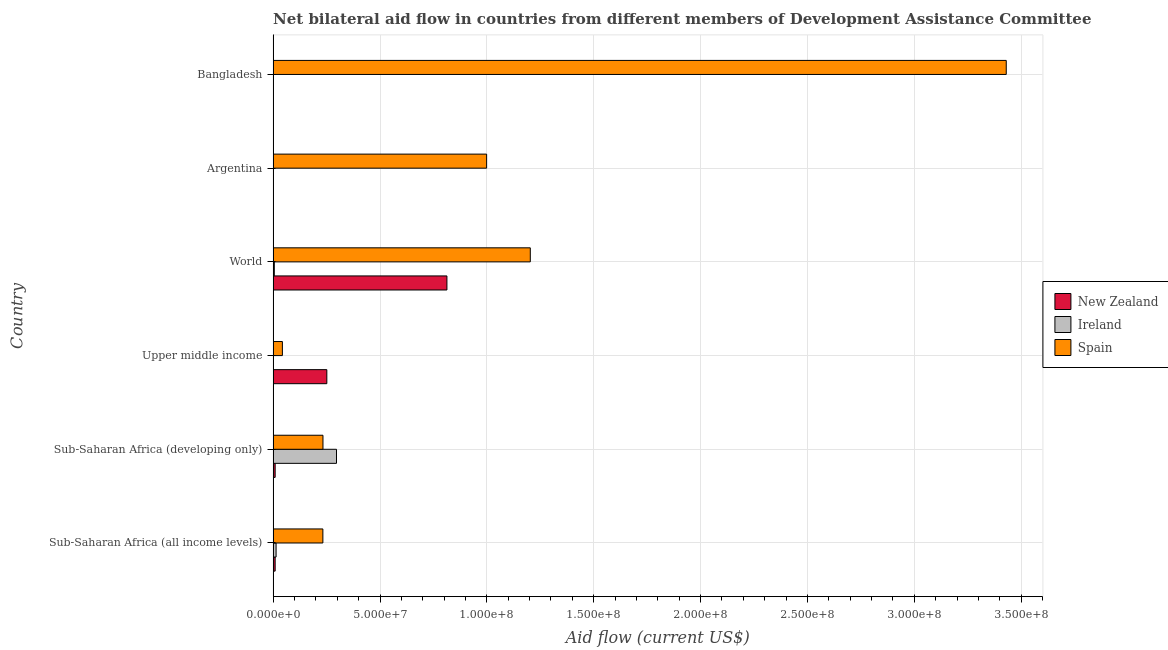How many different coloured bars are there?
Provide a succinct answer. 3. How many bars are there on the 3rd tick from the top?
Your answer should be compact. 3. How many bars are there on the 6th tick from the bottom?
Your answer should be very brief. 3. What is the label of the 1st group of bars from the top?
Ensure brevity in your answer.  Bangladesh. In how many cases, is the number of bars for a given country not equal to the number of legend labels?
Give a very brief answer. 0. What is the amount of aid provided by spain in Upper middle income?
Offer a terse response. 4.34e+06. Across all countries, what is the maximum amount of aid provided by new zealand?
Ensure brevity in your answer.  8.13e+07. Across all countries, what is the minimum amount of aid provided by ireland?
Keep it short and to the point. 2.00e+04. In which country was the amount of aid provided by spain maximum?
Your response must be concise. Bangladesh. In which country was the amount of aid provided by spain minimum?
Your answer should be very brief. Upper middle income. What is the total amount of aid provided by ireland in the graph?
Keep it short and to the point. 3.17e+07. What is the difference between the amount of aid provided by ireland in Sub-Saharan Africa (all income levels) and that in Upper middle income?
Provide a succinct answer. 1.30e+06. What is the difference between the amount of aid provided by ireland in World and the amount of aid provided by new zealand in Upper middle income?
Your answer should be compact. -2.46e+07. What is the average amount of aid provided by new zealand per country?
Your answer should be compact. 1.81e+07. What is the difference between the amount of aid provided by spain and amount of aid provided by ireland in Bangladesh?
Ensure brevity in your answer.  3.43e+08. In how many countries, is the amount of aid provided by spain greater than 50000000 US$?
Ensure brevity in your answer.  3. What is the ratio of the amount of aid provided by new zealand in Bangladesh to that in Sub-Saharan Africa (all income levels)?
Offer a very short reply. 0.05. What is the difference between the highest and the second highest amount of aid provided by ireland?
Ensure brevity in your answer.  2.83e+07. What is the difference between the highest and the lowest amount of aid provided by new zealand?
Offer a terse response. 8.13e+07. In how many countries, is the amount of aid provided by ireland greater than the average amount of aid provided by ireland taken over all countries?
Provide a succinct answer. 1. What does the 3rd bar from the top in Sub-Saharan Africa (developing only) represents?
Your response must be concise. New Zealand. How many bars are there?
Your response must be concise. 18. Are all the bars in the graph horizontal?
Offer a terse response. Yes. How many countries are there in the graph?
Make the answer very short. 6. Are the values on the major ticks of X-axis written in scientific E-notation?
Make the answer very short. Yes. Does the graph contain any zero values?
Make the answer very short. No. Does the graph contain grids?
Your answer should be very brief. Yes. Where does the legend appear in the graph?
Your answer should be very brief. Center right. How are the legend labels stacked?
Your answer should be compact. Vertical. What is the title of the graph?
Ensure brevity in your answer.  Net bilateral aid flow in countries from different members of Development Assistance Committee. What is the label or title of the Y-axis?
Offer a very short reply. Country. What is the Aid flow (current US$) in New Zealand in Sub-Saharan Africa (all income levels)?
Ensure brevity in your answer.  9.50e+05. What is the Aid flow (current US$) of Ireland in Sub-Saharan Africa (all income levels)?
Your response must be concise. 1.39e+06. What is the Aid flow (current US$) of Spain in Sub-Saharan Africa (all income levels)?
Give a very brief answer. 2.33e+07. What is the Aid flow (current US$) in New Zealand in Sub-Saharan Africa (developing only)?
Your response must be concise. 9.50e+05. What is the Aid flow (current US$) in Ireland in Sub-Saharan Africa (developing only)?
Give a very brief answer. 2.96e+07. What is the Aid flow (current US$) in Spain in Sub-Saharan Africa (developing only)?
Ensure brevity in your answer.  2.33e+07. What is the Aid flow (current US$) of New Zealand in Upper middle income?
Provide a succinct answer. 2.51e+07. What is the Aid flow (current US$) of Ireland in Upper middle income?
Make the answer very short. 9.00e+04. What is the Aid flow (current US$) in Spain in Upper middle income?
Provide a short and direct response. 4.34e+06. What is the Aid flow (current US$) of New Zealand in World?
Ensure brevity in your answer.  8.13e+07. What is the Aid flow (current US$) of Ireland in World?
Your response must be concise. 5.60e+05. What is the Aid flow (current US$) in Spain in World?
Offer a very short reply. 1.20e+08. What is the Aid flow (current US$) of New Zealand in Argentina?
Your answer should be compact. 3.00e+04. What is the Aid flow (current US$) in Ireland in Argentina?
Ensure brevity in your answer.  2.00e+04. What is the Aid flow (current US$) of Spain in Argentina?
Provide a short and direct response. 9.99e+07. What is the Aid flow (current US$) of Spain in Bangladesh?
Make the answer very short. 3.43e+08. Across all countries, what is the maximum Aid flow (current US$) in New Zealand?
Provide a succinct answer. 8.13e+07. Across all countries, what is the maximum Aid flow (current US$) in Ireland?
Your answer should be very brief. 2.96e+07. Across all countries, what is the maximum Aid flow (current US$) of Spain?
Your answer should be compact. 3.43e+08. Across all countries, what is the minimum Aid flow (current US$) in New Zealand?
Offer a terse response. 3.00e+04. Across all countries, what is the minimum Aid flow (current US$) in Spain?
Provide a short and direct response. 4.34e+06. What is the total Aid flow (current US$) of New Zealand in the graph?
Offer a very short reply. 1.08e+08. What is the total Aid flow (current US$) of Ireland in the graph?
Keep it short and to the point. 3.17e+07. What is the total Aid flow (current US$) of Spain in the graph?
Your answer should be very brief. 6.14e+08. What is the difference between the Aid flow (current US$) in Ireland in Sub-Saharan Africa (all income levels) and that in Sub-Saharan Africa (developing only)?
Ensure brevity in your answer.  -2.83e+07. What is the difference between the Aid flow (current US$) of New Zealand in Sub-Saharan Africa (all income levels) and that in Upper middle income?
Offer a very short reply. -2.42e+07. What is the difference between the Aid flow (current US$) in Ireland in Sub-Saharan Africa (all income levels) and that in Upper middle income?
Offer a very short reply. 1.30e+06. What is the difference between the Aid flow (current US$) in Spain in Sub-Saharan Africa (all income levels) and that in Upper middle income?
Provide a short and direct response. 1.89e+07. What is the difference between the Aid flow (current US$) of New Zealand in Sub-Saharan Africa (all income levels) and that in World?
Provide a succinct answer. -8.04e+07. What is the difference between the Aid flow (current US$) of Ireland in Sub-Saharan Africa (all income levels) and that in World?
Ensure brevity in your answer.  8.30e+05. What is the difference between the Aid flow (current US$) of Spain in Sub-Saharan Africa (all income levels) and that in World?
Your response must be concise. -9.70e+07. What is the difference between the Aid flow (current US$) in New Zealand in Sub-Saharan Africa (all income levels) and that in Argentina?
Your answer should be compact. 9.20e+05. What is the difference between the Aid flow (current US$) of Ireland in Sub-Saharan Africa (all income levels) and that in Argentina?
Keep it short and to the point. 1.37e+06. What is the difference between the Aid flow (current US$) in Spain in Sub-Saharan Africa (all income levels) and that in Argentina?
Ensure brevity in your answer.  -7.66e+07. What is the difference between the Aid flow (current US$) in Ireland in Sub-Saharan Africa (all income levels) and that in Bangladesh?
Your response must be concise. 1.37e+06. What is the difference between the Aid flow (current US$) in Spain in Sub-Saharan Africa (all income levels) and that in Bangladesh?
Make the answer very short. -3.20e+08. What is the difference between the Aid flow (current US$) of New Zealand in Sub-Saharan Africa (developing only) and that in Upper middle income?
Ensure brevity in your answer.  -2.42e+07. What is the difference between the Aid flow (current US$) of Ireland in Sub-Saharan Africa (developing only) and that in Upper middle income?
Your answer should be compact. 2.96e+07. What is the difference between the Aid flow (current US$) in Spain in Sub-Saharan Africa (developing only) and that in Upper middle income?
Give a very brief answer. 1.90e+07. What is the difference between the Aid flow (current US$) in New Zealand in Sub-Saharan Africa (developing only) and that in World?
Ensure brevity in your answer.  -8.04e+07. What is the difference between the Aid flow (current US$) of Ireland in Sub-Saharan Africa (developing only) and that in World?
Offer a very short reply. 2.91e+07. What is the difference between the Aid flow (current US$) of Spain in Sub-Saharan Africa (developing only) and that in World?
Offer a terse response. -9.70e+07. What is the difference between the Aid flow (current US$) in New Zealand in Sub-Saharan Africa (developing only) and that in Argentina?
Keep it short and to the point. 9.20e+05. What is the difference between the Aid flow (current US$) in Ireland in Sub-Saharan Africa (developing only) and that in Argentina?
Offer a terse response. 2.96e+07. What is the difference between the Aid flow (current US$) of Spain in Sub-Saharan Africa (developing only) and that in Argentina?
Make the answer very short. -7.66e+07. What is the difference between the Aid flow (current US$) in New Zealand in Sub-Saharan Africa (developing only) and that in Bangladesh?
Provide a short and direct response. 9.00e+05. What is the difference between the Aid flow (current US$) in Ireland in Sub-Saharan Africa (developing only) and that in Bangladesh?
Your answer should be very brief. 2.96e+07. What is the difference between the Aid flow (current US$) of Spain in Sub-Saharan Africa (developing only) and that in Bangladesh?
Your response must be concise. -3.20e+08. What is the difference between the Aid flow (current US$) of New Zealand in Upper middle income and that in World?
Give a very brief answer. -5.62e+07. What is the difference between the Aid flow (current US$) in Ireland in Upper middle income and that in World?
Your answer should be compact. -4.70e+05. What is the difference between the Aid flow (current US$) in Spain in Upper middle income and that in World?
Your answer should be compact. -1.16e+08. What is the difference between the Aid flow (current US$) of New Zealand in Upper middle income and that in Argentina?
Ensure brevity in your answer.  2.51e+07. What is the difference between the Aid flow (current US$) in Ireland in Upper middle income and that in Argentina?
Provide a short and direct response. 7.00e+04. What is the difference between the Aid flow (current US$) in Spain in Upper middle income and that in Argentina?
Provide a short and direct response. -9.56e+07. What is the difference between the Aid flow (current US$) of New Zealand in Upper middle income and that in Bangladesh?
Your response must be concise. 2.51e+07. What is the difference between the Aid flow (current US$) of Spain in Upper middle income and that in Bangladesh?
Provide a short and direct response. -3.39e+08. What is the difference between the Aid flow (current US$) in New Zealand in World and that in Argentina?
Make the answer very short. 8.13e+07. What is the difference between the Aid flow (current US$) of Ireland in World and that in Argentina?
Your answer should be compact. 5.40e+05. What is the difference between the Aid flow (current US$) of Spain in World and that in Argentina?
Ensure brevity in your answer.  2.04e+07. What is the difference between the Aid flow (current US$) in New Zealand in World and that in Bangladesh?
Offer a terse response. 8.13e+07. What is the difference between the Aid flow (current US$) of Ireland in World and that in Bangladesh?
Keep it short and to the point. 5.40e+05. What is the difference between the Aid flow (current US$) of Spain in World and that in Bangladesh?
Your answer should be compact. -2.23e+08. What is the difference between the Aid flow (current US$) of Spain in Argentina and that in Bangladesh?
Your answer should be compact. -2.43e+08. What is the difference between the Aid flow (current US$) of New Zealand in Sub-Saharan Africa (all income levels) and the Aid flow (current US$) of Ireland in Sub-Saharan Africa (developing only)?
Provide a short and direct response. -2.87e+07. What is the difference between the Aid flow (current US$) of New Zealand in Sub-Saharan Africa (all income levels) and the Aid flow (current US$) of Spain in Sub-Saharan Africa (developing only)?
Provide a short and direct response. -2.24e+07. What is the difference between the Aid flow (current US$) of Ireland in Sub-Saharan Africa (all income levels) and the Aid flow (current US$) of Spain in Sub-Saharan Africa (developing only)?
Ensure brevity in your answer.  -2.19e+07. What is the difference between the Aid flow (current US$) in New Zealand in Sub-Saharan Africa (all income levels) and the Aid flow (current US$) in Ireland in Upper middle income?
Provide a succinct answer. 8.60e+05. What is the difference between the Aid flow (current US$) of New Zealand in Sub-Saharan Africa (all income levels) and the Aid flow (current US$) of Spain in Upper middle income?
Ensure brevity in your answer.  -3.39e+06. What is the difference between the Aid flow (current US$) in Ireland in Sub-Saharan Africa (all income levels) and the Aid flow (current US$) in Spain in Upper middle income?
Provide a succinct answer. -2.95e+06. What is the difference between the Aid flow (current US$) of New Zealand in Sub-Saharan Africa (all income levels) and the Aid flow (current US$) of Spain in World?
Give a very brief answer. -1.19e+08. What is the difference between the Aid flow (current US$) of Ireland in Sub-Saharan Africa (all income levels) and the Aid flow (current US$) of Spain in World?
Offer a terse response. -1.19e+08. What is the difference between the Aid flow (current US$) in New Zealand in Sub-Saharan Africa (all income levels) and the Aid flow (current US$) in Ireland in Argentina?
Your response must be concise. 9.30e+05. What is the difference between the Aid flow (current US$) in New Zealand in Sub-Saharan Africa (all income levels) and the Aid flow (current US$) in Spain in Argentina?
Your answer should be compact. -9.89e+07. What is the difference between the Aid flow (current US$) in Ireland in Sub-Saharan Africa (all income levels) and the Aid flow (current US$) in Spain in Argentina?
Make the answer very short. -9.85e+07. What is the difference between the Aid flow (current US$) in New Zealand in Sub-Saharan Africa (all income levels) and the Aid flow (current US$) in Ireland in Bangladesh?
Provide a succinct answer. 9.30e+05. What is the difference between the Aid flow (current US$) in New Zealand in Sub-Saharan Africa (all income levels) and the Aid flow (current US$) in Spain in Bangladesh?
Your response must be concise. -3.42e+08. What is the difference between the Aid flow (current US$) in Ireland in Sub-Saharan Africa (all income levels) and the Aid flow (current US$) in Spain in Bangladesh?
Offer a very short reply. -3.42e+08. What is the difference between the Aid flow (current US$) of New Zealand in Sub-Saharan Africa (developing only) and the Aid flow (current US$) of Ireland in Upper middle income?
Provide a short and direct response. 8.60e+05. What is the difference between the Aid flow (current US$) in New Zealand in Sub-Saharan Africa (developing only) and the Aid flow (current US$) in Spain in Upper middle income?
Make the answer very short. -3.39e+06. What is the difference between the Aid flow (current US$) in Ireland in Sub-Saharan Africa (developing only) and the Aid flow (current US$) in Spain in Upper middle income?
Offer a very short reply. 2.53e+07. What is the difference between the Aid flow (current US$) in New Zealand in Sub-Saharan Africa (developing only) and the Aid flow (current US$) in Ireland in World?
Your answer should be compact. 3.90e+05. What is the difference between the Aid flow (current US$) in New Zealand in Sub-Saharan Africa (developing only) and the Aid flow (current US$) in Spain in World?
Give a very brief answer. -1.19e+08. What is the difference between the Aid flow (current US$) in Ireland in Sub-Saharan Africa (developing only) and the Aid flow (current US$) in Spain in World?
Provide a short and direct response. -9.07e+07. What is the difference between the Aid flow (current US$) in New Zealand in Sub-Saharan Africa (developing only) and the Aid flow (current US$) in Ireland in Argentina?
Make the answer very short. 9.30e+05. What is the difference between the Aid flow (current US$) of New Zealand in Sub-Saharan Africa (developing only) and the Aid flow (current US$) of Spain in Argentina?
Offer a terse response. -9.89e+07. What is the difference between the Aid flow (current US$) of Ireland in Sub-Saharan Africa (developing only) and the Aid flow (current US$) of Spain in Argentina?
Give a very brief answer. -7.02e+07. What is the difference between the Aid flow (current US$) in New Zealand in Sub-Saharan Africa (developing only) and the Aid flow (current US$) in Ireland in Bangladesh?
Make the answer very short. 9.30e+05. What is the difference between the Aid flow (current US$) of New Zealand in Sub-Saharan Africa (developing only) and the Aid flow (current US$) of Spain in Bangladesh?
Your answer should be compact. -3.42e+08. What is the difference between the Aid flow (current US$) of Ireland in Sub-Saharan Africa (developing only) and the Aid flow (current US$) of Spain in Bangladesh?
Provide a succinct answer. -3.13e+08. What is the difference between the Aid flow (current US$) in New Zealand in Upper middle income and the Aid flow (current US$) in Ireland in World?
Your answer should be very brief. 2.46e+07. What is the difference between the Aid flow (current US$) of New Zealand in Upper middle income and the Aid flow (current US$) of Spain in World?
Provide a short and direct response. -9.52e+07. What is the difference between the Aid flow (current US$) in Ireland in Upper middle income and the Aid flow (current US$) in Spain in World?
Offer a terse response. -1.20e+08. What is the difference between the Aid flow (current US$) in New Zealand in Upper middle income and the Aid flow (current US$) in Ireland in Argentina?
Your answer should be very brief. 2.51e+07. What is the difference between the Aid flow (current US$) of New Zealand in Upper middle income and the Aid flow (current US$) of Spain in Argentina?
Provide a short and direct response. -7.48e+07. What is the difference between the Aid flow (current US$) in Ireland in Upper middle income and the Aid flow (current US$) in Spain in Argentina?
Provide a short and direct response. -9.98e+07. What is the difference between the Aid flow (current US$) of New Zealand in Upper middle income and the Aid flow (current US$) of Ireland in Bangladesh?
Your answer should be compact. 2.51e+07. What is the difference between the Aid flow (current US$) of New Zealand in Upper middle income and the Aid flow (current US$) of Spain in Bangladesh?
Offer a very short reply. -3.18e+08. What is the difference between the Aid flow (current US$) in Ireland in Upper middle income and the Aid flow (current US$) in Spain in Bangladesh?
Your answer should be compact. -3.43e+08. What is the difference between the Aid flow (current US$) in New Zealand in World and the Aid flow (current US$) in Ireland in Argentina?
Offer a terse response. 8.13e+07. What is the difference between the Aid flow (current US$) of New Zealand in World and the Aid flow (current US$) of Spain in Argentina?
Make the answer very short. -1.86e+07. What is the difference between the Aid flow (current US$) of Ireland in World and the Aid flow (current US$) of Spain in Argentina?
Your answer should be compact. -9.93e+07. What is the difference between the Aid flow (current US$) of New Zealand in World and the Aid flow (current US$) of Ireland in Bangladesh?
Give a very brief answer. 8.13e+07. What is the difference between the Aid flow (current US$) in New Zealand in World and the Aid flow (current US$) in Spain in Bangladesh?
Offer a very short reply. -2.62e+08. What is the difference between the Aid flow (current US$) of Ireland in World and the Aid flow (current US$) of Spain in Bangladesh?
Your response must be concise. -3.42e+08. What is the difference between the Aid flow (current US$) of New Zealand in Argentina and the Aid flow (current US$) of Ireland in Bangladesh?
Give a very brief answer. 10000. What is the difference between the Aid flow (current US$) in New Zealand in Argentina and the Aid flow (current US$) in Spain in Bangladesh?
Give a very brief answer. -3.43e+08. What is the difference between the Aid flow (current US$) of Ireland in Argentina and the Aid flow (current US$) of Spain in Bangladesh?
Provide a succinct answer. -3.43e+08. What is the average Aid flow (current US$) of New Zealand per country?
Your answer should be compact. 1.81e+07. What is the average Aid flow (current US$) of Ireland per country?
Your answer should be very brief. 5.29e+06. What is the average Aid flow (current US$) of Spain per country?
Offer a terse response. 1.02e+08. What is the difference between the Aid flow (current US$) of New Zealand and Aid flow (current US$) of Ireland in Sub-Saharan Africa (all income levels)?
Ensure brevity in your answer.  -4.40e+05. What is the difference between the Aid flow (current US$) in New Zealand and Aid flow (current US$) in Spain in Sub-Saharan Africa (all income levels)?
Your response must be concise. -2.23e+07. What is the difference between the Aid flow (current US$) of Ireland and Aid flow (current US$) of Spain in Sub-Saharan Africa (all income levels)?
Give a very brief answer. -2.19e+07. What is the difference between the Aid flow (current US$) of New Zealand and Aid flow (current US$) of Ireland in Sub-Saharan Africa (developing only)?
Give a very brief answer. -2.87e+07. What is the difference between the Aid flow (current US$) of New Zealand and Aid flow (current US$) of Spain in Sub-Saharan Africa (developing only)?
Give a very brief answer. -2.24e+07. What is the difference between the Aid flow (current US$) of Ireland and Aid flow (current US$) of Spain in Sub-Saharan Africa (developing only)?
Your answer should be compact. 6.33e+06. What is the difference between the Aid flow (current US$) in New Zealand and Aid flow (current US$) in Ireland in Upper middle income?
Provide a short and direct response. 2.50e+07. What is the difference between the Aid flow (current US$) in New Zealand and Aid flow (current US$) in Spain in Upper middle income?
Ensure brevity in your answer.  2.08e+07. What is the difference between the Aid flow (current US$) in Ireland and Aid flow (current US$) in Spain in Upper middle income?
Make the answer very short. -4.25e+06. What is the difference between the Aid flow (current US$) in New Zealand and Aid flow (current US$) in Ireland in World?
Make the answer very short. 8.08e+07. What is the difference between the Aid flow (current US$) of New Zealand and Aid flow (current US$) of Spain in World?
Your response must be concise. -3.90e+07. What is the difference between the Aid flow (current US$) in Ireland and Aid flow (current US$) in Spain in World?
Your answer should be very brief. -1.20e+08. What is the difference between the Aid flow (current US$) in New Zealand and Aid flow (current US$) in Ireland in Argentina?
Your answer should be very brief. 10000. What is the difference between the Aid flow (current US$) of New Zealand and Aid flow (current US$) of Spain in Argentina?
Your answer should be compact. -9.99e+07. What is the difference between the Aid flow (current US$) in Ireland and Aid flow (current US$) in Spain in Argentina?
Provide a short and direct response. -9.99e+07. What is the difference between the Aid flow (current US$) of New Zealand and Aid flow (current US$) of Spain in Bangladesh?
Ensure brevity in your answer.  -3.43e+08. What is the difference between the Aid flow (current US$) of Ireland and Aid flow (current US$) of Spain in Bangladesh?
Offer a terse response. -3.43e+08. What is the ratio of the Aid flow (current US$) of New Zealand in Sub-Saharan Africa (all income levels) to that in Sub-Saharan Africa (developing only)?
Make the answer very short. 1. What is the ratio of the Aid flow (current US$) in Ireland in Sub-Saharan Africa (all income levels) to that in Sub-Saharan Africa (developing only)?
Keep it short and to the point. 0.05. What is the ratio of the Aid flow (current US$) in Spain in Sub-Saharan Africa (all income levels) to that in Sub-Saharan Africa (developing only)?
Ensure brevity in your answer.  1. What is the ratio of the Aid flow (current US$) in New Zealand in Sub-Saharan Africa (all income levels) to that in Upper middle income?
Keep it short and to the point. 0.04. What is the ratio of the Aid flow (current US$) of Ireland in Sub-Saharan Africa (all income levels) to that in Upper middle income?
Provide a succinct answer. 15.44. What is the ratio of the Aid flow (current US$) of Spain in Sub-Saharan Africa (all income levels) to that in Upper middle income?
Your response must be concise. 5.36. What is the ratio of the Aid flow (current US$) of New Zealand in Sub-Saharan Africa (all income levels) to that in World?
Offer a very short reply. 0.01. What is the ratio of the Aid flow (current US$) of Ireland in Sub-Saharan Africa (all income levels) to that in World?
Provide a short and direct response. 2.48. What is the ratio of the Aid flow (current US$) of Spain in Sub-Saharan Africa (all income levels) to that in World?
Keep it short and to the point. 0.19. What is the ratio of the Aid flow (current US$) in New Zealand in Sub-Saharan Africa (all income levels) to that in Argentina?
Your answer should be compact. 31.67. What is the ratio of the Aid flow (current US$) of Ireland in Sub-Saharan Africa (all income levels) to that in Argentina?
Your response must be concise. 69.5. What is the ratio of the Aid flow (current US$) of Spain in Sub-Saharan Africa (all income levels) to that in Argentina?
Provide a short and direct response. 0.23. What is the ratio of the Aid flow (current US$) of Ireland in Sub-Saharan Africa (all income levels) to that in Bangladesh?
Provide a succinct answer. 69.5. What is the ratio of the Aid flow (current US$) of Spain in Sub-Saharan Africa (all income levels) to that in Bangladesh?
Offer a very short reply. 0.07. What is the ratio of the Aid flow (current US$) in New Zealand in Sub-Saharan Africa (developing only) to that in Upper middle income?
Provide a succinct answer. 0.04. What is the ratio of the Aid flow (current US$) of Ireland in Sub-Saharan Africa (developing only) to that in Upper middle income?
Keep it short and to the point. 329.44. What is the ratio of the Aid flow (current US$) of Spain in Sub-Saharan Africa (developing only) to that in Upper middle income?
Make the answer very short. 5.37. What is the ratio of the Aid flow (current US$) of New Zealand in Sub-Saharan Africa (developing only) to that in World?
Make the answer very short. 0.01. What is the ratio of the Aid flow (current US$) in Ireland in Sub-Saharan Africa (developing only) to that in World?
Your response must be concise. 52.95. What is the ratio of the Aid flow (current US$) of Spain in Sub-Saharan Africa (developing only) to that in World?
Ensure brevity in your answer.  0.19. What is the ratio of the Aid flow (current US$) in New Zealand in Sub-Saharan Africa (developing only) to that in Argentina?
Offer a very short reply. 31.67. What is the ratio of the Aid flow (current US$) of Ireland in Sub-Saharan Africa (developing only) to that in Argentina?
Provide a succinct answer. 1482.5. What is the ratio of the Aid flow (current US$) of Spain in Sub-Saharan Africa (developing only) to that in Argentina?
Provide a succinct answer. 0.23. What is the ratio of the Aid flow (current US$) in Ireland in Sub-Saharan Africa (developing only) to that in Bangladesh?
Make the answer very short. 1482.5. What is the ratio of the Aid flow (current US$) of Spain in Sub-Saharan Africa (developing only) to that in Bangladesh?
Ensure brevity in your answer.  0.07. What is the ratio of the Aid flow (current US$) in New Zealand in Upper middle income to that in World?
Offer a very short reply. 0.31. What is the ratio of the Aid flow (current US$) in Ireland in Upper middle income to that in World?
Ensure brevity in your answer.  0.16. What is the ratio of the Aid flow (current US$) in Spain in Upper middle income to that in World?
Provide a short and direct response. 0.04. What is the ratio of the Aid flow (current US$) of New Zealand in Upper middle income to that in Argentina?
Provide a succinct answer. 837.67. What is the ratio of the Aid flow (current US$) of Ireland in Upper middle income to that in Argentina?
Ensure brevity in your answer.  4.5. What is the ratio of the Aid flow (current US$) of Spain in Upper middle income to that in Argentina?
Provide a succinct answer. 0.04. What is the ratio of the Aid flow (current US$) in New Zealand in Upper middle income to that in Bangladesh?
Give a very brief answer. 502.6. What is the ratio of the Aid flow (current US$) in Ireland in Upper middle income to that in Bangladesh?
Give a very brief answer. 4.5. What is the ratio of the Aid flow (current US$) of Spain in Upper middle income to that in Bangladesh?
Offer a terse response. 0.01. What is the ratio of the Aid flow (current US$) of New Zealand in World to that in Argentina?
Offer a terse response. 2710.33. What is the ratio of the Aid flow (current US$) of Ireland in World to that in Argentina?
Make the answer very short. 28. What is the ratio of the Aid flow (current US$) of Spain in World to that in Argentina?
Offer a very short reply. 1.2. What is the ratio of the Aid flow (current US$) of New Zealand in World to that in Bangladesh?
Offer a terse response. 1626.2. What is the ratio of the Aid flow (current US$) in Ireland in World to that in Bangladesh?
Your response must be concise. 28. What is the ratio of the Aid flow (current US$) in Spain in World to that in Bangladesh?
Make the answer very short. 0.35. What is the ratio of the Aid flow (current US$) in New Zealand in Argentina to that in Bangladesh?
Offer a very short reply. 0.6. What is the ratio of the Aid flow (current US$) in Ireland in Argentina to that in Bangladesh?
Provide a short and direct response. 1. What is the ratio of the Aid flow (current US$) of Spain in Argentina to that in Bangladesh?
Ensure brevity in your answer.  0.29. What is the difference between the highest and the second highest Aid flow (current US$) in New Zealand?
Give a very brief answer. 5.62e+07. What is the difference between the highest and the second highest Aid flow (current US$) of Ireland?
Offer a terse response. 2.83e+07. What is the difference between the highest and the second highest Aid flow (current US$) in Spain?
Give a very brief answer. 2.23e+08. What is the difference between the highest and the lowest Aid flow (current US$) in New Zealand?
Give a very brief answer. 8.13e+07. What is the difference between the highest and the lowest Aid flow (current US$) of Ireland?
Make the answer very short. 2.96e+07. What is the difference between the highest and the lowest Aid flow (current US$) in Spain?
Give a very brief answer. 3.39e+08. 